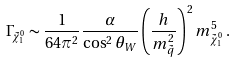Convert formula to latex. <formula><loc_0><loc_0><loc_500><loc_500>\Gamma _ { \tilde { \chi } _ { 1 } ^ { 0 } } \sim \frac { 1 } { 6 4 \pi ^ { 2 } } \frac { \alpha } { \cos ^ { 2 } \theta _ { W } } \left ( \frac { h } { m _ { \tilde { q } } ^ { 2 } } \right ) ^ { 2 } m _ { \tilde { \chi } _ { 1 } ^ { 0 } } ^ { 5 } \, .</formula> 